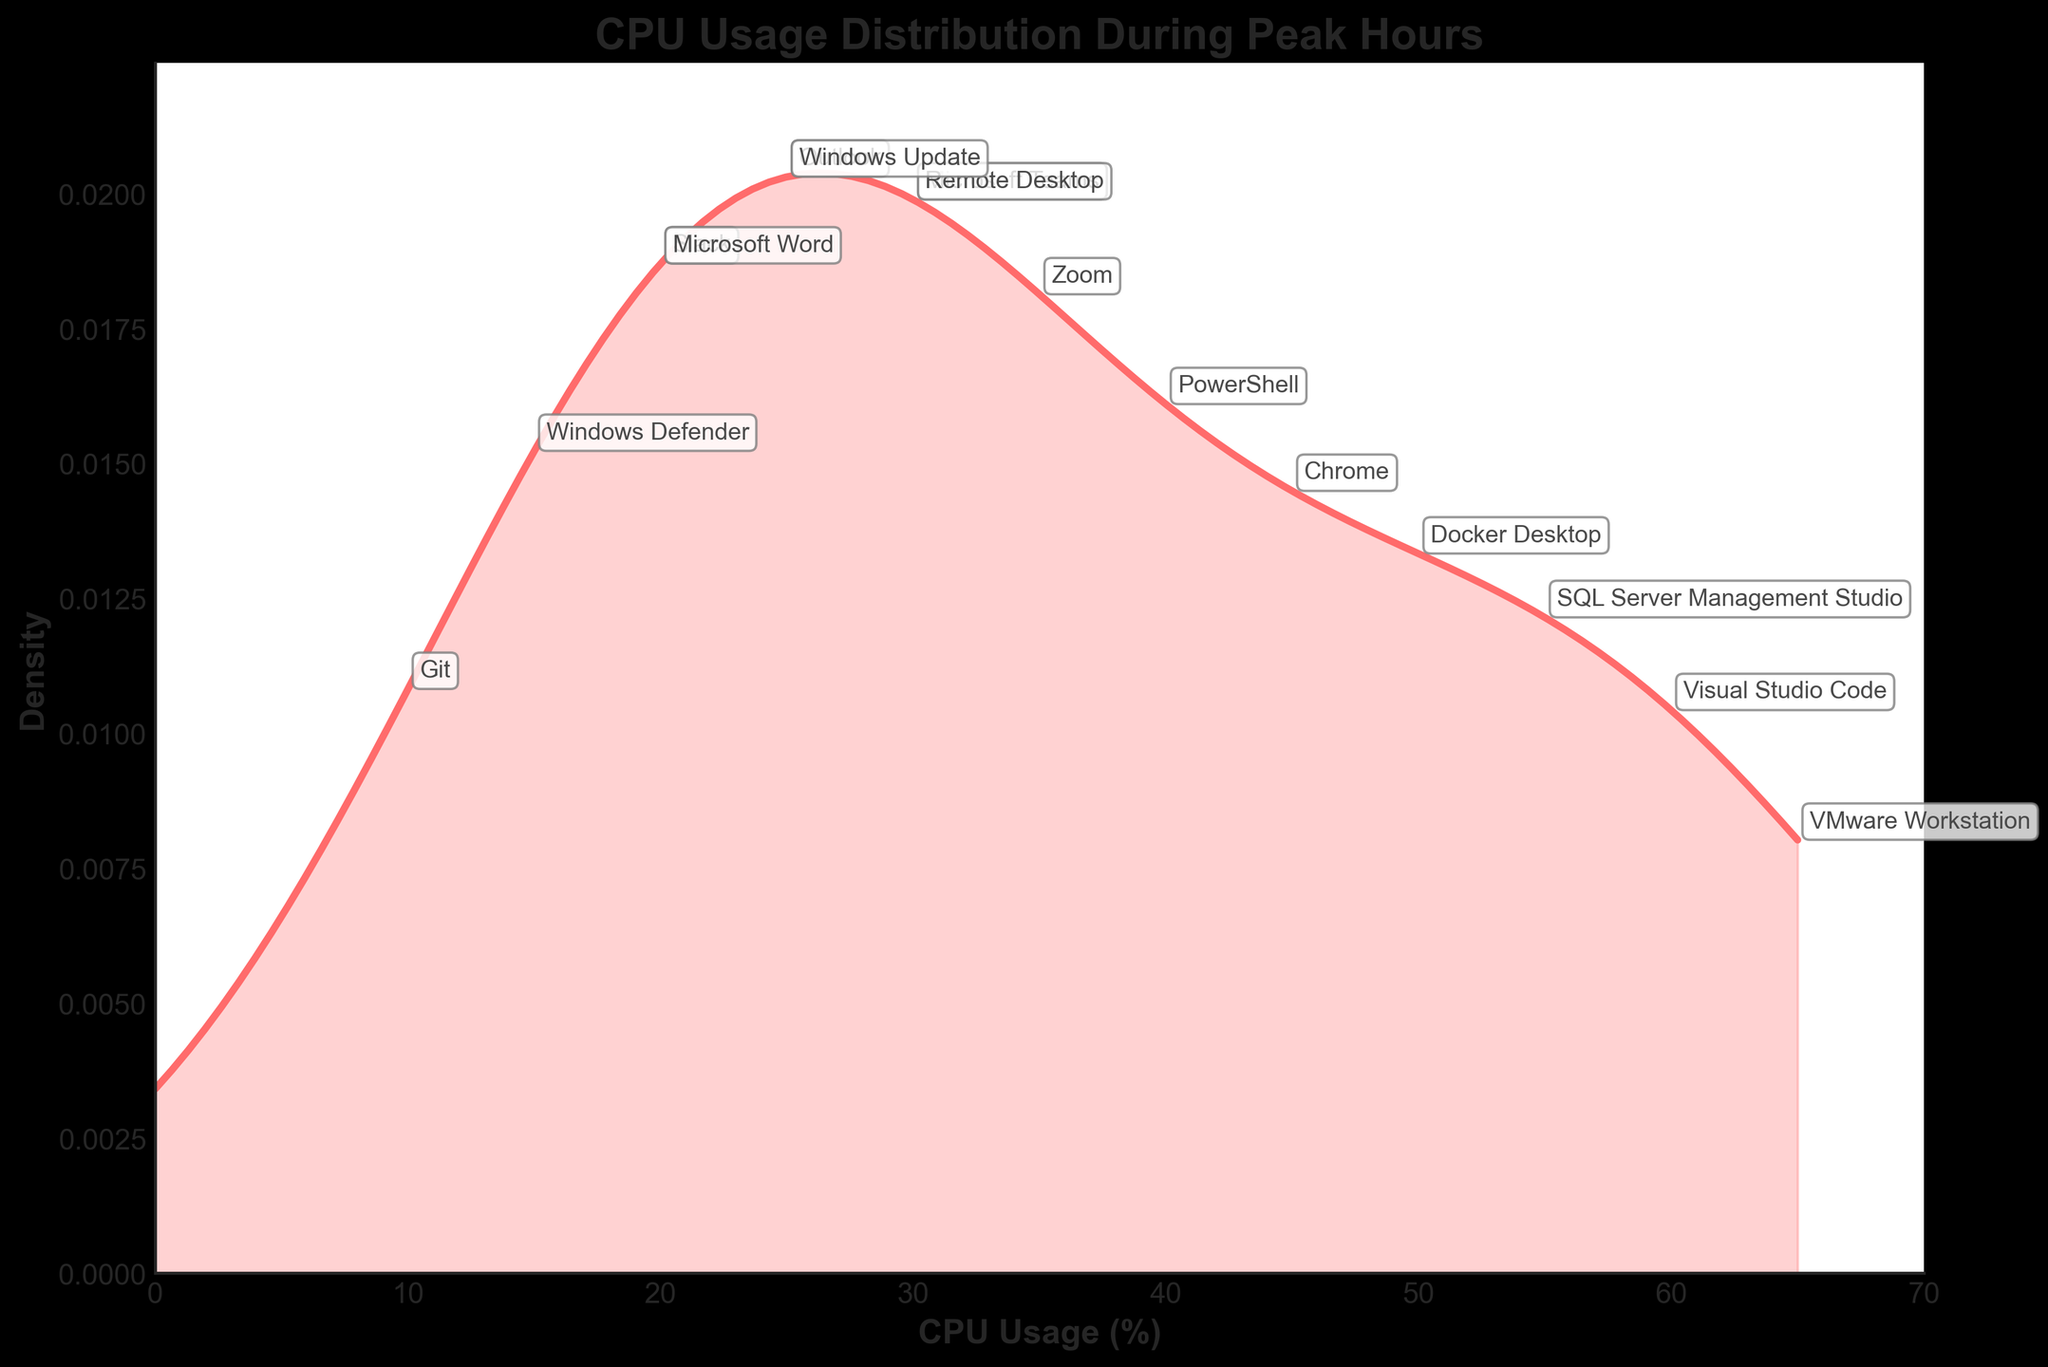What is the title of the density plot? The title of the chart is prominently placed at the top of the chart area. It usually describes the overall topic of the plot.
Answer: CPU Usage Distribution During Peak Hours What is the x-axis label? The x-axis label describes what data is represented along the horizontal axis of the plot.
Answer: CPU Usage (%) Which application has the highest CPU usage? By looking at the individual points annotated on the plot, you can find the application corresponding to the highest CPU usage value.
Answer: VMware Workstation Which CPU usage value has the highest density? To find the CPU usage value with the highest density, look at the peak of the density curve. The x-coordinate of this peak represents the CPU usage value with the highest density.
Answer: Approx. 30 How many applications have a CPU usage above 50%? Count the number of annotations on the right side of 50 on the x-axis.
Answer: Three (Visual Studio Code, Docker Desktop, VMware Workstation) Is there a significant drop in density after 40% CPU usage? Analyze the shape of the density curve after the 40% mark. If the density significantly drops, it is indicative of fewer applications having CPU usage higher than 40%.
Answer: Yes Compare the CPU usage of Zoom and Microsoft Teams. Which one is higher and by how much? Find the annotations for both Zoom and Microsoft Teams. Compare the x-coordinates (CPU Usage) of these points.
Answer: Zoom's CPU usage is 35%, and Microsoft Teams' CPU usage is 30%, so Zoom's is 5% higher What is the density value at 15% CPU usage? Locate the density curve above the 15% CPU usage mark on the x-axis and read the corresponding y-value.
Answer: Approx. 0.015 (based on visual estimation) Which applications have a CPU usage below 25%? Identify the annotations on the left side of 25 on the x-axis.
Answer: Slack, Windows Defender, Git, Microsoft Word, Windows Update 